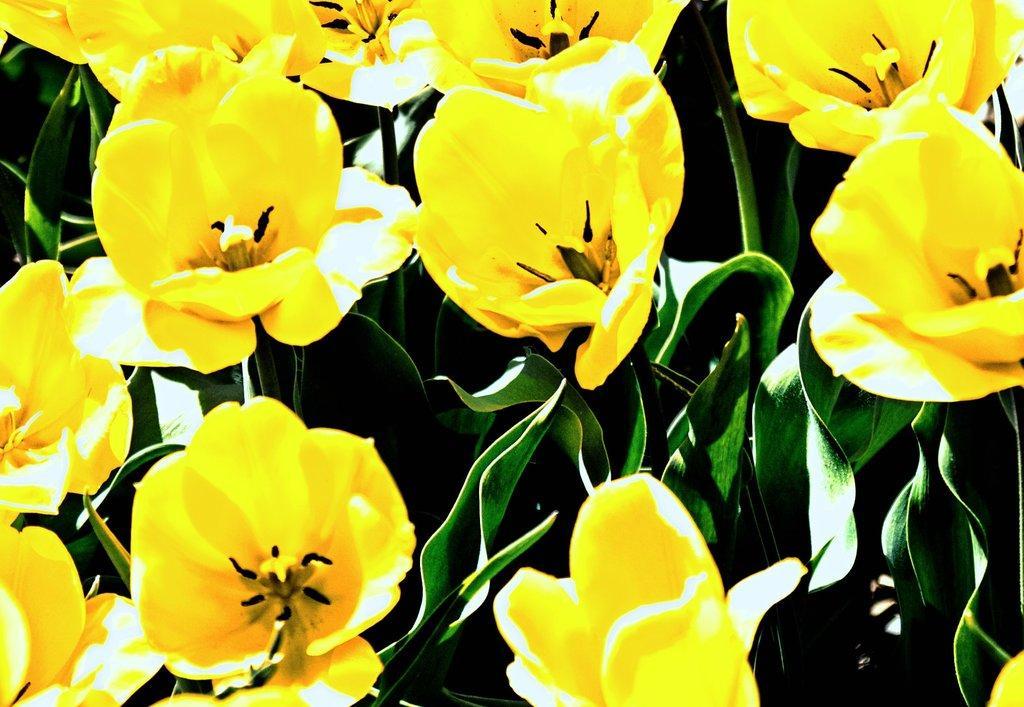In one or two sentences, can you explain what this image depicts? In this image there are some flowers and plants. 